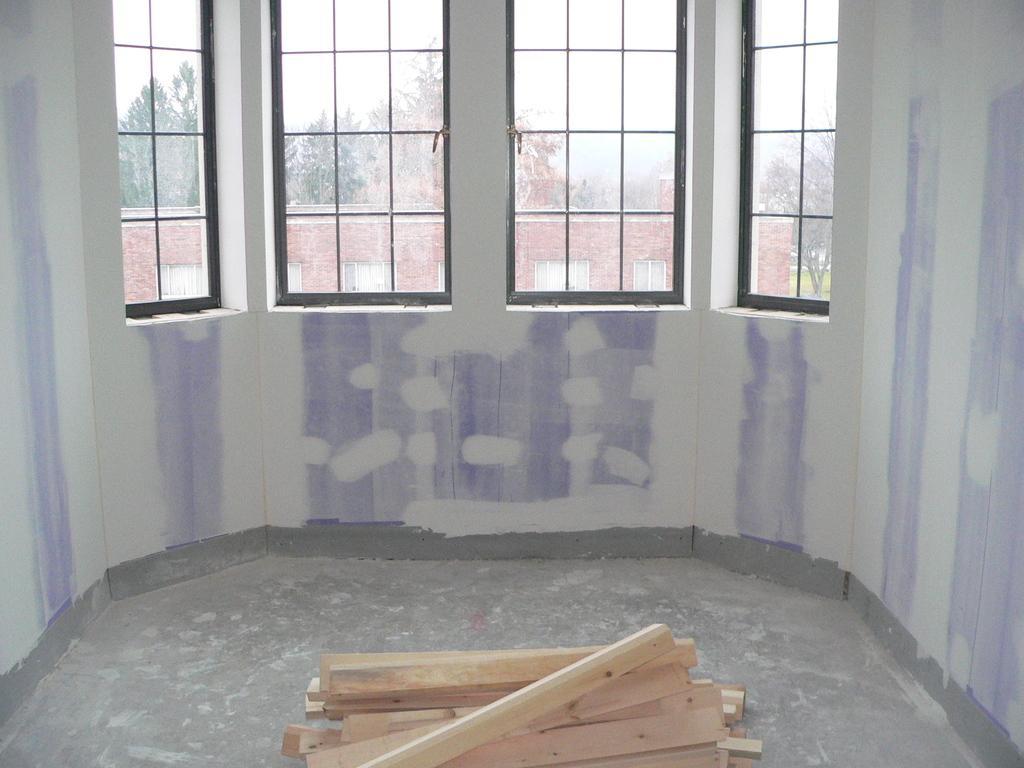Describe this image in one or two sentences. This picture might be taken inside the room. In this image, in the middle, we can see wood sticks. In the background, we can see glass windows, buildings, trees. On the top, we can see a sky. 